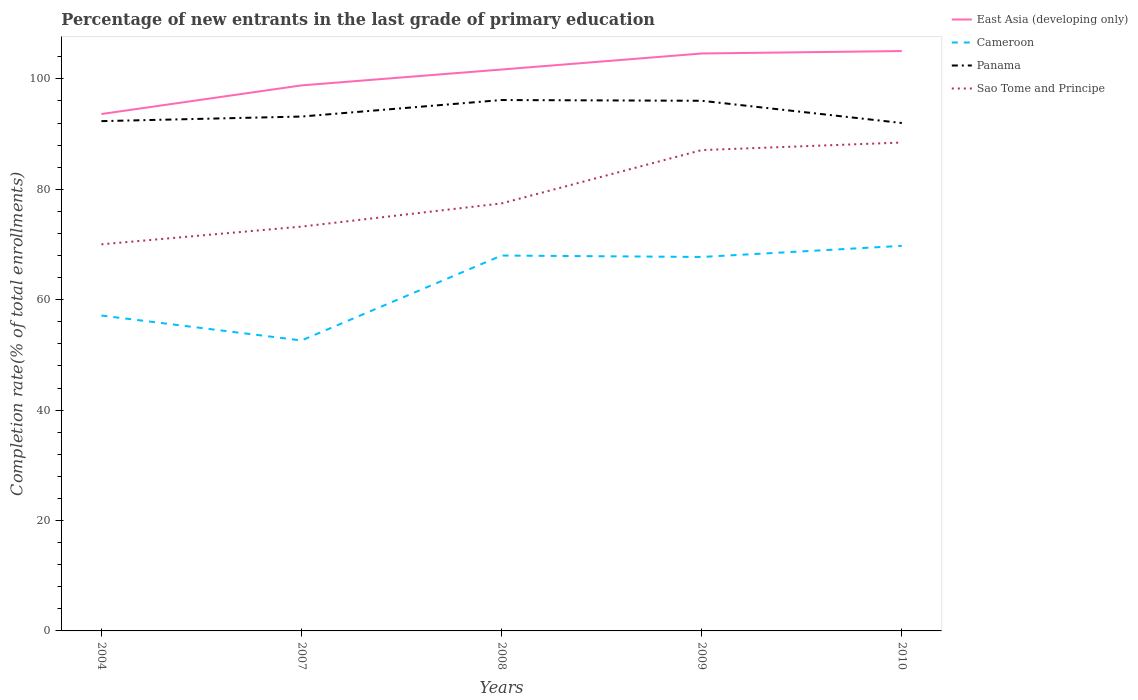Does the line corresponding to Sao Tome and Principe intersect with the line corresponding to East Asia (developing only)?
Your response must be concise. No. Across all years, what is the maximum percentage of new entrants in Sao Tome and Principe?
Offer a terse response. 70.03. In which year was the percentage of new entrants in Panama maximum?
Give a very brief answer. 2010. What is the total percentage of new entrants in Panama in the graph?
Your answer should be compact. -0.83. What is the difference between the highest and the second highest percentage of new entrants in Panama?
Offer a terse response. 4.16. What is the difference between the highest and the lowest percentage of new entrants in East Asia (developing only)?
Your answer should be very brief. 3. What is the difference between two consecutive major ticks on the Y-axis?
Provide a succinct answer. 20. Are the values on the major ticks of Y-axis written in scientific E-notation?
Your answer should be compact. No. Does the graph contain any zero values?
Your response must be concise. No. How are the legend labels stacked?
Keep it short and to the point. Vertical. What is the title of the graph?
Provide a succinct answer. Percentage of new entrants in the last grade of primary education. Does "Heavily indebted poor countries" appear as one of the legend labels in the graph?
Provide a short and direct response. No. What is the label or title of the X-axis?
Offer a terse response. Years. What is the label or title of the Y-axis?
Ensure brevity in your answer.  Completion rate(% of total enrollments). What is the Completion rate(% of total enrollments) in East Asia (developing only) in 2004?
Provide a succinct answer. 93.64. What is the Completion rate(% of total enrollments) of Cameroon in 2004?
Make the answer very short. 57.13. What is the Completion rate(% of total enrollments) of Panama in 2004?
Offer a terse response. 92.35. What is the Completion rate(% of total enrollments) in Sao Tome and Principe in 2004?
Your answer should be compact. 70.03. What is the Completion rate(% of total enrollments) in East Asia (developing only) in 2007?
Make the answer very short. 98.83. What is the Completion rate(% of total enrollments) in Cameroon in 2007?
Offer a very short reply. 52.62. What is the Completion rate(% of total enrollments) of Panama in 2007?
Your answer should be very brief. 93.18. What is the Completion rate(% of total enrollments) in Sao Tome and Principe in 2007?
Provide a succinct answer. 73.25. What is the Completion rate(% of total enrollments) of East Asia (developing only) in 2008?
Provide a succinct answer. 101.7. What is the Completion rate(% of total enrollments) of Cameroon in 2008?
Give a very brief answer. 68. What is the Completion rate(% of total enrollments) in Panama in 2008?
Your answer should be very brief. 96.17. What is the Completion rate(% of total enrollments) of Sao Tome and Principe in 2008?
Keep it short and to the point. 77.45. What is the Completion rate(% of total enrollments) of East Asia (developing only) in 2009?
Your answer should be very brief. 104.61. What is the Completion rate(% of total enrollments) of Cameroon in 2009?
Provide a succinct answer. 67.75. What is the Completion rate(% of total enrollments) of Panama in 2009?
Keep it short and to the point. 96.04. What is the Completion rate(% of total enrollments) of Sao Tome and Principe in 2009?
Your answer should be very brief. 87.11. What is the Completion rate(% of total enrollments) of East Asia (developing only) in 2010?
Offer a terse response. 105.05. What is the Completion rate(% of total enrollments) of Cameroon in 2010?
Offer a terse response. 69.76. What is the Completion rate(% of total enrollments) in Panama in 2010?
Keep it short and to the point. 92.01. What is the Completion rate(% of total enrollments) in Sao Tome and Principe in 2010?
Offer a very short reply. 88.48. Across all years, what is the maximum Completion rate(% of total enrollments) in East Asia (developing only)?
Offer a very short reply. 105.05. Across all years, what is the maximum Completion rate(% of total enrollments) of Cameroon?
Offer a very short reply. 69.76. Across all years, what is the maximum Completion rate(% of total enrollments) of Panama?
Make the answer very short. 96.17. Across all years, what is the maximum Completion rate(% of total enrollments) of Sao Tome and Principe?
Your answer should be very brief. 88.48. Across all years, what is the minimum Completion rate(% of total enrollments) in East Asia (developing only)?
Give a very brief answer. 93.64. Across all years, what is the minimum Completion rate(% of total enrollments) of Cameroon?
Make the answer very short. 52.62. Across all years, what is the minimum Completion rate(% of total enrollments) in Panama?
Provide a short and direct response. 92.01. Across all years, what is the minimum Completion rate(% of total enrollments) in Sao Tome and Principe?
Provide a succinct answer. 70.03. What is the total Completion rate(% of total enrollments) of East Asia (developing only) in the graph?
Offer a terse response. 503.82. What is the total Completion rate(% of total enrollments) of Cameroon in the graph?
Your answer should be compact. 315.26. What is the total Completion rate(% of total enrollments) of Panama in the graph?
Provide a short and direct response. 469.76. What is the total Completion rate(% of total enrollments) in Sao Tome and Principe in the graph?
Your answer should be compact. 396.31. What is the difference between the Completion rate(% of total enrollments) of East Asia (developing only) in 2004 and that in 2007?
Make the answer very short. -5.19. What is the difference between the Completion rate(% of total enrollments) of Cameroon in 2004 and that in 2007?
Make the answer very short. 4.51. What is the difference between the Completion rate(% of total enrollments) in Panama in 2004 and that in 2007?
Keep it short and to the point. -0.83. What is the difference between the Completion rate(% of total enrollments) in Sao Tome and Principe in 2004 and that in 2007?
Ensure brevity in your answer.  -3.21. What is the difference between the Completion rate(% of total enrollments) in East Asia (developing only) in 2004 and that in 2008?
Offer a terse response. -8.06. What is the difference between the Completion rate(% of total enrollments) of Cameroon in 2004 and that in 2008?
Make the answer very short. -10.87. What is the difference between the Completion rate(% of total enrollments) of Panama in 2004 and that in 2008?
Your answer should be compact. -3.82. What is the difference between the Completion rate(% of total enrollments) of Sao Tome and Principe in 2004 and that in 2008?
Give a very brief answer. -7.41. What is the difference between the Completion rate(% of total enrollments) of East Asia (developing only) in 2004 and that in 2009?
Your answer should be very brief. -10.97. What is the difference between the Completion rate(% of total enrollments) of Cameroon in 2004 and that in 2009?
Keep it short and to the point. -10.61. What is the difference between the Completion rate(% of total enrollments) in Panama in 2004 and that in 2009?
Give a very brief answer. -3.69. What is the difference between the Completion rate(% of total enrollments) in Sao Tome and Principe in 2004 and that in 2009?
Offer a terse response. -17.07. What is the difference between the Completion rate(% of total enrollments) of East Asia (developing only) in 2004 and that in 2010?
Provide a succinct answer. -11.41. What is the difference between the Completion rate(% of total enrollments) of Cameroon in 2004 and that in 2010?
Keep it short and to the point. -12.62. What is the difference between the Completion rate(% of total enrollments) in Panama in 2004 and that in 2010?
Give a very brief answer. 0.34. What is the difference between the Completion rate(% of total enrollments) in Sao Tome and Principe in 2004 and that in 2010?
Your answer should be very brief. -18.44. What is the difference between the Completion rate(% of total enrollments) of East Asia (developing only) in 2007 and that in 2008?
Your answer should be compact. -2.88. What is the difference between the Completion rate(% of total enrollments) in Cameroon in 2007 and that in 2008?
Ensure brevity in your answer.  -15.38. What is the difference between the Completion rate(% of total enrollments) in Panama in 2007 and that in 2008?
Offer a very short reply. -2.99. What is the difference between the Completion rate(% of total enrollments) of Sao Tome and Principe in 2007 and that in 2008?
Offer a very short reply. -4.2. What is the difference between the Completion rate(% of total enrollments) in East Asia (developing only) in 2007 and that in 2009?
Offer a very short reply. -5.78. What is the difference between the Completion rate(% of total enrollments) of Cameroon in 2007 and that in 2009?
Provide a succinct answer. -15.13. What is the difference between the Completion rate(% of total enrollments) in Panama in 2007 and that in 2009?
Provide a short and direct response. -2.86. What is the difference between the Completion rate(% of total enrollments) of Sao Tome and Principe in 2007 and that in 2009?
Give a very brief answer. -13.86. What is the difference between the Completion rate(% of total enrollments) of East Asia (developing only) in 2007 and that in 2010?
Give a very brief answer. -6.22. What is the difference between the Completion rate(% of total enrollments) of Cameroon in 2007 and that in 2010?
Provide a succinct answer. -17.14. What is the difference between the Completion rate(% of total enrollments) in Panama in 2007 and that in 2010?
Give a very brief answer. 1.17. What is the difference between the Completion rate(% of total enrollments) of Sao Tome and Principe in 2007 and that in 2010?
Provide a short and direct response. -15.23. What is the difference between the Completion rate(% of total enrollments) in East Asia (developing only) in 2008 and that in 2009?
Make the answer very short. -2.9. What is the difference between the Completion rate(% of total enrollments) of Cameroon in 2008 and that in 2009?
Provide a short and direct response. 0.26. What is the difference between the Completion rate(% of total enrollments) in Panama in 2008 and that in 2009?
Provide a short and direct response. 0.13. What is the difference between the Completion rate(% of total enrollments) of Sao Tome and Principe in 2008 and that in 2009?
Your answer should be very brief. -9.66. What is the difference between the Completion rate(% of total enrollments) in East Asia (developing only) in 2008 and that in 2010?
Your response must be concise. -3.35. What is the difference between the Completion rate(% of total enrollments) in Cameroon in 2008 and that in 2010?
Your response must be concise. -1.75. What is the difference between the Completion rate(% of total enrollments) in Panama in 2008 and that in 2010?
Offer a terse response. 4.16. What is the difference between the Completion rate(% of total enrollments) in Sao Tome and Principe in 2008 and that in 2010?
Keep it short and to the point. -11.03. What is the difference between the Completion rate(% of total enrollments) of East Asia (developing only) in 2009 and that in 2010?
Your answer should be compact. -0.44. What is the difference between the Completion rate(% of total enrollments) of Cameroon in 2009 and that in 2010?
Offer a very short reply. -2.01. What is the difference between the Completion rate(% of total enrollments) of Panama in 2009 and that in 2010?
Provide a succinct answer. 4.03. What is the difference between the Completion rate(% of total enrollments) in Sao Tome and Principe in 2009 and that in 2010?
Your answer should be very brief. -1.37. What is the difference between the Completion rate(% of total enrollments) of East Asia (developing only) in 2004 and the Completion rate(% of total enrollments) of Cameroon in 2007?
Keep it short and to the point. 41.02. What is the difference between the Completion rate(% of total enrollments) of East Asia (developing only) in 2004 and the Completion rate(% of total enrollments) of Panama in 2007?
Your answer should be compact. 0.45. What is the difference between the Completion rate(% of total enrollments) in East Asia (developing only) in 2004 and the Completion rate(% of total enrollments) in Sao Tome and Principe in 2007?
Provide a succinct answer. 20.39. What is the difference between the Completion rate(% of total enrollments) in Cameroon in 2004 and the Completion rate(% of total enrollments) in Panama in 2007?
Provide a succinct answer. -36.05. What is the difference between the Completion rate(% of total enrollments) in Cameroon in 2004 and the Completion rate(% of total enrollments) in Sao Tome and Principe in 2007?
Ensure brevity in your answer.  -16.11. What is the difference between the Completion rate(% of total enrollments) in Panama in 2004 and the Completion rate(% of total enrollments) in Sao Tome and Principe in 2007?
Give a very brief answer. 19.1. What is the difference between the Completion rate(% of total enrollments) of East Asia (developing only) in 2004 and the Completion rate(% of total enrollments) of Cameroon in 2008?
Your response must be concise. 25.64. What is the difference between the Completion rate(% of total enrollments) in East Asia (developing only) in 2004 and the Completion rate(% of total enrollments) in Panama in 2008?
Your answer should be very brief. -2.54. What is the difference between the Completion rate(% of total enrollments) in East Asia (developing only) in 2004 and the Completion rate(% of total enrollments) in Sao Tome and Principe in 2008?
Provide a succinct answer. 16.19. What is the difference between the Completion rate(% of total enrollments) of Cameroon in 2004 and the Completion rate(% of total enrollments) of Panama in 2008?
Offer a terse response. -39.04. What is the difference between the Completion rate(% of total enrollments) of Cameroon in 2004 and the Completion rate(% of total enrollments) of Sao Tome and Principe in 2008?
Provide a short and direct response. -20.31. What is the difference between the Completion rate(% of total enrollments) in Panama in 2004 and the Completion rate(% of total enrollments) in Sao Tome and Principe in 2008?
Ensure brevity in your answer.  14.91. What is the difference between the Completion rate(% of total enrollments) in East Asia (developing only) in 2004 and the Completion rate(% of total enrollments) in Cameroon in 2009?
Provide a short and direct response. 25.89. What is the difference between the Completion rate(% of total enrollments) of East Asia (developing only) in 2004 and the Completion rate(% of total enrollments) of Panama in 2009?
Your response must be concise. -2.4. What is the difference between the Completion rate(% of total enrollments) in East Asia (developing only) in 2004 and the Completion rate(% of total enrollments) in Sao Tome and Principe in 2009?
Your answer should be compact. 6.53. What is the difference between the Completion rate(% of total enrollments) of Cameroon in 2004 and the Completion rate(% of total enrollments) of Panama in 2009?
Keep it short and to the point. -38.91. What is the difference between the Completion rate(% of total enrollments) in Cameroon in 2004 and the Completion rate(% of total enrollments) in Sao Tome and Principe in 2009?
Your response must be concise. -29.97. What is the difference between the Completion rate(% of total enrollments) of Panama in 2004 and the Completion rate(% of total enrollments) of Sao Tome and Principe in 2009?
Your response must be concise. 5.24. What is the difference between the Completion rate(% of total enrollments) of East Asia (developing only) in 2004 and the Completion rate(% of total enrollments) of Cameroon in 2010?
Offer a very short reply. 23.88. What is the difference between the Completion rate(% of total enrollments) in East Asia (developing only) in 2004 and the Completion rate(% of total enrollments) in Panama in 2010?
Ensure brevity in your answer.  1.62. What is the difference between the Completion rate(% of total enrollments) of East Asia (developing only) in 2004 and the Completion rate(% of total enrollments) of Sao Tome and Principe in 2010?
Provide a short and direct response. 5.16. What is the difference between the Completion rate(% of total enrollments) of Cameroon in 2004 and the Completion rate(% of total enrollments) of Panama in 2010?
Make the answer very short. -34.88. What is the difference between the Completion rate(% of total enrollments) in Cameroon in 2004 and the Completion rate(% of total enrollments) in Sao Tome and Principe in 2010?
Make the answer very short. -31.34. What is the difference between the Completion rate(% of total enrollments) in Panama in 2004 and the Completion rate(% of total enrollments) in Sao Tome and Principe in 2010?
Make the answer very short. 3.88. What is the difference between the Completion rate(% of total enrollments) in East Asia (developing only) in 2007 and the Completion rate(% of total enrollments) in Cameroon in 2008?
Offer a terse response. 30.82. What is the difference between the Completion rate(% of total enrollments) of East Asia (developing only) in 2007 and the Completion rate(% of total enrollments) of Panama in 2008?
Give a very brief answer. 2.65. What is the difference between the Completion rate(% of total enrollments) in East Asia (developing only) in 2007 and the Completion rate(% of total enrollments) in Sao Tome and Principe in 2008?
Give a very brief answer. 21.38. What is the difference between the Completion rate(% of total enrollments) of Cameroon in 2007 and the Completion rate(% of total enrollments) of Panama in 2008?
Give a very brief answer. -43.56. What is the difference between the Completion rate(% of total enrollments) in Cameroon in 2007 and the Completion rate(% of total enrollments) in Sao Tome and Principe in 2008?
Offer a very short reply. -24.83. What is the difference between the Completion rate(% of total enrollments) in Panama in 2007 and the Completion rate(% of total enrollments) in Sao Tome and Principe in 2008?
Your response must be concise. 15.74. What is the difference between the Completion rate(% of total enrollments) in East Asia (developing only) in 2007 and the Completion rate(% of total enrollments) in Cameroon in 2009?
Your answer should be compact. 31.08. What is the difference between the Completion rate(% of total enrollments) in East Asia (developing only) in 2007 and the Completion rate(% of total enrollments) in Panama in 2009?
Your response must be concise. 2.79. What is the difference between the Completion rate(% of total enrollments) of East Asia (developing only) in 2007 and the Completion rate(% of total enrollments) of Sao Tome and Principe in 2009?
Your answer should be compact. 11.72. What is the difference between the Completion rate(% of total enrollments) of Cameroon in 2007 and the Completion rate(% of total enrollments) of Panama in 2009?
Make the answer very short. -43.42. What is the difference between the Completion rate(% of total enrollments) of Cameroon in 2007 and the Completion rate(% of total enrollments) of Sao Tome and Principe in 2009?
Offer a very short reply. -34.49. What is the difference between the Completion rate(% of total enrollments) of Panama in 2007 and the Completion rate(% of total enrollments) of Sao Tome and Principe in 2009?
Your response must be concise. 6.08. What is the difference between the Completion rate(% of total enrollments) in East Asia (developing only) in 2007 and the Completion rate(% of total enrollments) in Cameroon in 2010?
Offer a terse response. 29.07. What is the difference between the Completion rate(% of total enrollments) of East Asia (developing only) in 2007 and the Completion rate(% of total enrollments) of Panama in 2010?
Provide a short and direct response. 6.81. What is the difference between the Completion rate(% of total enrollments) of East Asia (developing only) in 2007 and the Completion rate(% of total enrollments) of Sao Tome and Principe in 2010?
Provide a succinct answer. 10.35. What is the difference between the Completion rate(% of total enrollments) in Cameroon in 2007 and the Completion rate(% of total enrollments) in Panama in 2010?
Keep it short and to the point. -39.4. What is the difference between the Completion rate(% of total enrollments) of Cameroon in 2007 and the Completion rate(% of total enrollments) of Sao Tome and Principe in 2010?
Make the answer very short. -35.86. What is the difference between the Completion rate(% of total enrollments) in Panama in 2007 and the Completion rate(% of total enrollments) in Sao Tome and Principe in 2010?
Offer a terse response. 4.71. What is the difference between the Completion rate(% of total enrollments) in East Asia (developing only) in 2008 and the Completion rate(% of total enrollments) in Cameroon in 2009?
Offer a very short reply. 33.96. What is the difference between the Completion rate(% of total enrollments) of East Asia (developing only) in 2008 and the Completion rate(% of total enrollments) of Panama in 2009?
Provide a short and direct response. 5.66. What is the difference between the Completion rate(% of total enrollments) in East Asia (developing only) in 2008 and the Completion rate(% of total enrollments) in Sao Tome and Principe in 2009?
Provide a succinct answer. 14.6. What is the difference between the Completion rate(% of total enrollments) in Cameroon in 2008 and the Completion rate(% of total enrollments) in Panama in 2009?
Offer a very short reply. -28.04. What is the difference between the Completion rate(% of total enrollments) of Cameroon in 2008 and the Completion rate(% of total enrollments) of Sao Tome and Principe in 2009?
Provide a short and direct response. -19.1. What is the difference between the Completion rate(% of total enrollments) of Panama in 2008 and the Completion rate(% of total enrollments) of Sao Tome and Principe in 2009?
Your answer should be very brief. 9.07. What is the difference between the Completion rate(% of total enrollments) of East Asia (developing only) in 2008 and the Completion rate(% of total enrollments) of Cameroon in 2010?
Provide a succinct answer. 31.95. What is the difference between the Completion rate(% of total enrollments) of East Asia (developing only) in 2008 and the Completion rate(% of total enrollments) of Panama in 2010?
Provide a succinct answer. 9.69. What is the difference between the Completion rate(% of total enrollments) of East Asia (developing only) in 2008 and the Completion rate(% of total enrollments) of Sao Tome and Principe in 2010?
Give a very brief answer. 13.23. What is the difference between the Completion rate(% of total enrollments) of Cameroon in 2008 and the Completion rate(% of total enrollments) of Panama in 2010?
Provide a short and direct response. -24.01. What is the difference between the Completion rate(% of total enrollments) in Cameroon in 2008 and the Completion rate(% of total enrollments) in Sao Tome and Principe in 2010?
Your answer should be very brief. -20.47. What is the difference between the Completion rate(% of total enrollments) of Panama in 2008 and the Completion rate(% of total enrollments) of Sao Tome and Principe in 2010?
Offer a very short reply. 7.7. What is the difference between the Completion rate(% of total enrollments) in East Asia (developing only) in 2009 and the Completion rate(% of total enrollments) in Cameroon in 2010?
Provide a succinct answer. 34.85. What is the difference between the Completion rate(% of total enrollments) of East Asia (developing only) in 2009 and the Completion rate(% of total enrollments) of Panama in 2010?
Keep it short and to the point. 12.59. What is the difference between the Completion rate(% of total enrollments) in East Asia (developing only) in 2009 and the Completion rate(% of total enrollments) in Sao Tome and Principe in 2010?
Provide a short and direct response. 16.13. What is the difference between the Completion rate(% of total enrollments) of Cameroon in 2009 and the Completion rate(% of total enrollments) of Panama in 2010?
Ensure brevity in your answer.  -24.27. What is the difference between the Completion rate(% of total enrollments) in Cameroon in 2009 and the Completion rate(% of total enrollments) in Sao Tome and Principe in 2010?
Provide a short and direct response. -20.73. What is the difference between the Completion rate(% of total enrollments) of Panama in 2009 and the Completion rate(% of total enrollments) of Sao Tome and Principe in 2010?
Give a very brief answer. 7.56. What is the average Completion rate(% of total enrollments) of East Asia (developing only) per year?
Keep it short and to the point. 100.76. What is the average Completion rate(% of total enrollments) of Cameroon per year?
Offer a terse response. 63.05. What is the average Completion rate(% of total enrollments) of Panama per year?
Make the answer very short. 93.95. What is the average Completion rate(% of total enrollments) of Sao Tome and Principe per year?
Your answer should be compact. 79.26. In the year 2004, what is the difference between the Completion rate(% of total enrollments) of East Asia (developing only) and Completion rate(% of total enrollments) of Cameroon?
Offer a terse response. 36.5. In the year 2004, what is the difference between the Completion rate(% of total enrollments) of East Asia (developing only) and Completion rate(% of total enrollments) of Panama?
Keep it short and to the point. 1.29. In the year 2004, what is the difference between the Completion rate(% of total enrollments) of East Asia (developing only) and Completion rate(% of total enrollments) of Sao Tome and Principe?
Provide a succinct answer. 23.6. In the year 2004, what is the difference between the Completion rate(% of total enrollments) of Cameroon and Completion rate(% of total enrollments) of Panama?
Offer a terse response. -35.22. In the year 2004, what is the difference between the Completion rate(% of total enrollments) in Cameroon and Completion rate(% of total enrollments) in Sao Tome and Principe?
Provide a short and direct response. -12.9. In the year 2004, what is the difference between the Completion rate(% of total enrollments) of Panama and Completion rate(% of total enrollments) of Sao Tome and Principe?
Offer a very short reply. 22.32. In the year 2007, what is the difference between the Completion rate(% of total enrollments) in East Asia (developing only) and Completion rate(% of total enrollments) in Cameroon?
Ensure brevity in your answer.  46.21. In the year 2007, what is the difference between the Completion rate(% of total enrollments) of East Asia (developing only) and Completion rate(% of total enrollments) of Panama?
Your response must be concise. 5.64. In the year 2007, what is the difference between the Completion rate(% of total enrollments) of East Asia (developing only) and Completion rate(% of total enrollments) of Sao Tome and Principe?
Your answer should be compact. 25.58. In the year 2007, what is the difference between the Completion rate(% of total enrollments) in Cameroon and Completion rate(% of total enrollments) in Panama?
Provide a short and direct response. -40.57. In the year 2007, what is the difference between the Completion rate(% of total enrollments) of Cameroon and Completion rate(% of total enrollments) of Sao Tome and Principe?
Your response must be concise. -20.63. In the year 2007, what is the difference between the Completion rate(% of total enrollments) of Panama and Completion rate(% of total enrollments) of Sao Tome and Principe?
Provide a succinct answer. 19.94. In the year 2008, what is the difference between the Completion rate(% of total enrollments) in East Asia (developing only) and Completion rate(% of total enrollments) in Cameroon?
Your answer should be very brief. 33.7. In the year 2008, what is the difference between the Completion rate(% of total enrollments) of East Asia (developing only) and Completion rate(% of total enrollments) of Panama?
Give a very brief answer. 5.53. In the year 2008, what is the difference between the Completion rate(% of total enrollments) in East Asia (developing only) and Completion rate(% of total enrollments) in Sao Tome and Principe?
Offer a very short reply. 24.26. In the year 2008, what is the difference between the Completion rate(% of total enrollments) in Cameroon and Completion rate(% of total enrollments) in Panama?
Your response must be concise. -28.17. In the year 2008, what is the difference between the Completion rate(% of total enrollments) of Cameroon and Completion rate(% of total enrollments) of Sao Tome and Principe?
Provide a short and direct response. -9.44. In the year 2008, what is the difference between the Completion rate(% of total enrollments) in Panama and Completion rate(% of total enrollments) in Sao Tome and Principe?
Offer a terse response. 18.73. In the year 2009, what is the difference between the Completion rate(% of total enrollments) in East Asia (developing only) and Completion rate(% of total enrollments) in Cameroon?
Offer a terse response. 36.86. In the year 2009, what is the difference between the Completion rate(% of total enrollments) in East Asia (developing only) and Completion rate(% of total enrollments) in Panama?
Offer a terse response. 8.56. In the year 2009, what is the difference between the Completion rate(% of total enrollments) of East Asia (developing only) and Completion rate(% of total enrollments) of Sao Tome and Principe?
Your answer should be compact. 17.5. In the year 2009, what is the difference between the Completion rate(% of total enrollments) in Cameroon and Completion rate(% of total enrollments) in Panama?
Keep it short and to the point. -28.29. In the year 2009, what is the difference between the Completion rate(% of total enrollments) of Cameroon and Completion rate(% of total enrollments) of Sao Tome and Principe?
Your answer should be very brief. -19.36. In the year 2009, what is the difference between the Completion rate(% of total enrollments) in Panama and Completion rate(% of total enrollments) in Sao Tome and Principe?
Provide a short and direct response. 8.93. In the year 2010, what is the difference between the Completion rate(% of total enrollments) in East Asia (developing only) and Completion rate(% of total enrollments) in Cameroon?
Give a very brief answer. 35.29. In the year 2010, what is the difference between the Completion rate(% of total enrollments) in East Asia (developing only) and Completion rate(% of total enrollments) in Panama?
Make the answer very short. 13.03. In the year 2010, what is the difference between the Completion rate(% of total enrollments) of East Asia (developing only) and Completion rate(% of total enrollments) of Sao Tome and Principe?
Your response must be concise. 16.57. In the year 2010, what is the difference between the Completion rate(% of total enrollments) of Cameroon and Completion rate(% of total enrollments) of Panama?
Make the answer very short. -22.26. In the year 2010, what is the difference between the Completion rate(% of total enrollments) in Cameroon and Completion rate(% of total enrollments) in Sao Tome and Principe?
Your answer should be very brief. -18.72. In the year 2010, what is the difference between the Completion rate(% of total enrollments) of Panama and Completion rate(% of total enrollments) of Sao Tome and Principe?
Offer a very short reply. 3.54. What is the ratio of the Completion rate(% of total enrollments) in East Asia (developing only) in 2004 to that in 2007?
Provide a succinct answer. 0.95. What is the ratio of the Completion rate(% of total enrollments) in Cameroon in 2004 to that in 2007?
Your answer should be compact. 1.09. What is the ratio of the Completion rate(% of total enrollments) of Panama in 2004 to that in 2007?
Make the answer very short. 0.99. What is the ratio of the Completion rate(% of total enrollments) in Sao Tome and Principe in 2004 to that in 2007?
Provide a succinct answer. 0.96. What is the ratio of the Completion rate(% of total enrollments) of East Asia (developing only) in 2004 to that in 2008?
Provide a short and direct response. 0.92. What is the ratio of the Completion rate(% of total enrollments) in Cameroon in 2004 to that in 2008?
Your response must be concise. 0.84. What is the ratio of the Completion rate(% of total enrollments) of Panama in 2004 to that in 2008?
Provide a succinct answer. 0.96. What is the ratio of the Completion rate(% of total enrollments) in Sao Tome and Principe in 2004 to that in 2008?
Ensure brevity in your answer.  0.9. What is the ratio of the Completion rate(% of total enrollments) in East Asia (developing only) in 2004 to that in 2009?
Keep it short and to the point. 0.9. What is the ratio of the Completion rate(% of total enrollments) of Cameroon in 2004 to that in 2009?
Your answer should be compact. 0.84. What is the ratio of the Completion rate(% of total enrollments) of Panama in 2004 to that in 2009?
Provide a short and direct response. 0.96. What is the ratio of the Completion rate(% of total enrollments) in Sao Tome and Principe in 2004 to that in 2009?
Provide a short and direct response. 0.8. What is the ratio of the Completion rate(% of total enrollments) in East Asia (developing only) in 2004 to that in 2010?
Offer a terse response. 0.89. What is the ratio of the Completion rate(% of total enrollments) in Cameroon in 2004 to that in 2010?
Offer a very short reply. 0.82. What is the ratio of the Completion rate(% of total enrollments) in Panama in 2004 to that in 2010?
Keep it short and to the point. 1. What is the ratio of the Completion rate(% of total enrollments) in Sao Tome and Principe in 2004 to that in 2010?
Make the answer very short. 0.79. What is the ratio of the Completion rate(% of total enrollments) in East Asia (developing only) in 2007 to that in 2008?
Keep it short and to the point. 0.97. What is the ratio of the Completion rate(% of total enrollments) of Cameroon in 2007 to that in 2008?
Offer a terse response. 0.77. What is the ratio of the Completion rate(% of total enrollments) of Panama in 2007 to that in 2008?
Offer a very short reply. 0.97. What is the ratio of the Completion rate(% of total enrollments) in Sao Tome and Principe in 2007 to that in 2008?
Offer a very short reply. 0.95. What is the ratio of the Completion rate(% of total enrollments) of East Asia (developing only) in 2007 to that in 2009?
Make the answer very short. 0.94. What is the ratio of the Completion rate(% of total enrollments) of Cameroon in 2007 to that in 2009?
Your answer should be compact. 0.78. What is the ratio of the Completion rate(% of total enrollments) in Panama in 2007 to that in 2009?
Provide a succinct answer. 0.97. What is the ratio of the Completion rate(% of total enrollments) of Sao Tome and Principe in 2007 to that in 2009?
Make the answer very short. 0.84. What is the ratio of the Completion rate(% of total enrollments) of East Asia (developing only) in 2007 to that in 2010?
Provide a succinct answer. 0.94. What is the ratio of the Completion rate(% of total enrollments) of Cameroon in 2007 to that in 2010?
Offer a very short reply. 0.75. What is the ratio of the Completion rate(% of total enrollments) in Panama in 2007 to that in 2010?
Keep it short and to the point. 1.01. What is the ratio of the Completion rate(% of total enrollments) of Sao Tome and Principe in 2007 to that in 2010?
Ensure brevity in your answer.  0.83. What is the ratio of the Completion rate(% of total enrollments) of East Asia (developing only) in 2008 to that in 2009?
Make the answer very short. 0.97. What is the ratio of the Completion rate(% of total enrollments) in Cameroon in 2008 to that in 2009?
Make the answer very short. 1. What is the ratio of the Completion rate(% of total enrollments) in Panama in 2008 to that in 2009?
Make the answer very short. 1. What is the ratio of the Completion rate(% of total enrollments) of Sao Tome and Principe in 2008 to that in 2009?
Offer a terse response. 0.89. What is the ratio of the Completion rate(% of total enrollments) of East Asia (developing only) in 2008 to that in 2010?
Offer a terse response. 0.97. What is the ratio of the Completion rate(% of total enrollments) of Cameroon in 2008 to that in 2010?
Your response must be concise. 0.97. What is the ratio of the Completion rate(% of total enrollments) of Panama in 2008 to that in 2010?
Ensure brevity in your answer.  1.05. What is the ratio of the Completion rate(% of total enrollments) in Sao Tome and Principe in 2008 to that in 2010?
Provide a short and direct response. 0.88. What is the ratio of the Completion rate(% of total enrollments) of Cameroon in 2009 to that in 2010?
Provide a short and direct response. 0.97. What is the ratio of the Completion rate(% of total enrollments) in Panama in 2009 to that in 2010?
Provide a succinct answer. 1.04. What is the ratio of the Completion rate(% of total enrollments) in Sao Tome and Principe in 2009 to that in 2010?
Your response must be concise. 0.98. What is the difference between the highest and the second highest Completion rate(% of total enrollments) of East Asia (developing only)?
Keep it short and to the point. 0.44. What is the difference between the highest and the second highest Completion rate(% of total enrollments) of Cameroon?
Offer a very short reply. 1.75. What is the difference between the highest and the second highest Completion rate(% of total enrollments) of Panama?
Provide a succinct answer. 0.13. What is the difference between the highest and the second highest Completion rate(% of total enrollments) of Sao Tome and Principe?
Keep it short and to the point. 1.37. What is the difference between the highest and the lowest Completion rate(% of total enrollments) in East Asia (developing only)?
Offer a terse response. 11.41. What is the difference between the highest and the lowest Completion rate(% of total enrollments) of Cameroon?
Offer a very short reply. 17.14. What is the difference between the highest and the lowest Completion rate(% of total enrollments) of Panama?
Ensure brevity in your answer.  4.16. What is the difference between the highest and the lowest Completion rate(% of total enrollments) in Sao Tome and Principe?
Offer a very short reply. 18.44. 